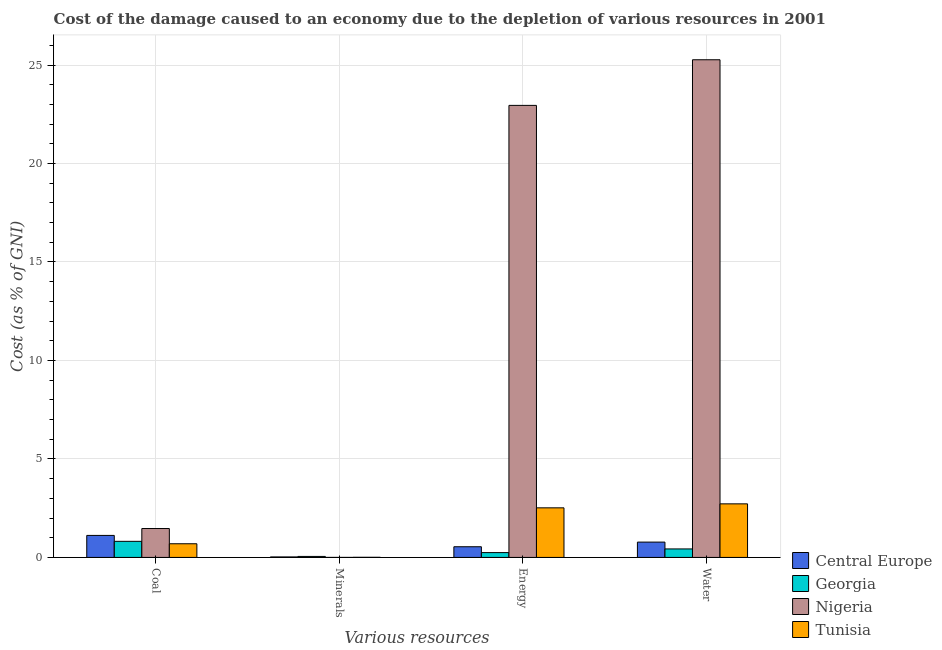How many groups of bars are there?
Offer a terse response. 4. Are the number of bars per tick equal to the number of legend labels?
Your answer should be very brief. Yes. Are the number of bars on each tick of the X-axis equal?
Give a very brief answer. Yes. How many bars are there on the 2nd tick from the left?
Provide a succinct answer. 4. How many bars are there on the 3rd tick from the right?
Your response must be concise. 4. What is the label of the 1st group of bars from the left?
Keep it short and to the point. Coal. What is the cost of damage due to depletion of minerals in Georgia?
Make the answer very short. 0.05. Across all countries, what is the maximum cost of damage due to depletion of coal?
Offer a terse response. 1.47. Across all countries, what is the minimum cost of damage due to depletion of water?
Ensure brevity in your answer.  0.43. In which country was the cost of damage due to depletion of energy maximum?
Ensure brevity in your answer.  Nigeria. In which country was the cost of damage due to depletion of minerals minimum?
Give a very brief answer. Nigeria. What is the total cost of damage due to depletion of coal in the graph?
Offer a terse response. 4.1. What is the difference between the cost of damage due to depletion of energy in Georgia and that in Tunisia?
Your response must be concise. -2.27. What is the difference between the cost of damage due to depletion of energy in Georgia and the cost of damage due to depletion of water in Tunisia?
Provide a short and direct response. -2.48. What is the average cost of damage due to depletion of coal per country?
Give a very brief answer. 1.02. What is the difference between the cost of damage due to depletion of minerals and cost of damage due to depletion of energy in Tunisia?
Your answer should be very brief. -2.51. What is the ratio of the cost of damage due to depletion of minerals in Tunisia to that in Central Europe?
Ensure brevity in your answer.  0.24. Is the cost of damage due to depletion of water in Central Europe less than that in Nigeria?
Your answer should be very brief. Yes. Is the difference between the cost of damage due to depletion of water in Tunisia and Central Europe greater than the difference between the cost of damage due to depletion of minerals in Tunisia and Central Europe?
Your answer should be very brief. Yes. What is the difference between the highest and the second highest cost of damage due to depletion of minerals?
Your response must be concise. 0.02. What is the difference between the highest and the lowest cost of damage due to depletion of water?
Ensure brevity in your answer.  24.84. In how many countries, is the cost of damage due to depletion of coal greater than the average cost of damage due to depletion of coal taken over all countries?
Ensure brevity in your answer.  2. Is the sum of the cost of damage due to depletion of energy in Tunisia and Georgia greater than the maximum cost of damage due to depletion of water across all countries?
Ensure brevity in your answer.  No. What does the 4th bar from the left in Energy represents?
Give a very brief answer. Tunisia. What does the 1st bar from the right in Energy represents?
Keep it short and to the point. Tunisia. Are the values on the major ticks of Y-axis written in scientific E-notation?
Your response must be concise. No. Does the graph contain any zero values?
Your answer should be compact. No. How are the legend labels stacked?
Provide a short and direct response. Vertical. What is the title of the graph?
Give a very brief answer. Cost of the damage caused to an economy due to the depletion of various resources in 2001 . Does "Central Europe" appear as one of the legend labels in the graph?
Ensure brevity in your answer.  Yes. What is the label or title of the X-axis?
Ensure brevity in your answer.  Various resources. What is the label or title of the Y-axis?
Give a very brief answer. Cost (as % of GNI). What is the Cost (as % of GNI) in Central Europe in Coal?
Ensure brevity in your answer.  1.12. What is the Cost (as % of GNI) of Georgia in Coal?
Your answer should be very brief. 0.82. What is the Cost (as % of GNI) of Nigeria in Coal?
Your answer should be very brief. 1.47. What is the Cost (as % of GNI) of Tunisia in Coal?
Your response must be concise. 0.69. What is the Cost (as % of GNI) in Central Europe in Minerals?
Ensure brevity in your answer.  0.03. What is the Cost (as % of GNI) of Georgia in Minerals?
Offer a terse response. 0.05. What is the Cost (as % of GNI) in Nigeria in Minerals?
Provide a succinct answer. 0. What is the Cost (as % of GNI) of Tunisia in Minerals?
Ensure brevity in your answer.  0.01. What is the Cost (as % of GNI) of Central Europe in Energy?
Keep it short and to the point. 0.54. What is the Cost (as % of GNI) in Georgia in Energy?
Your answer should be very brief. 0.24. What is the Cost (as % of GNI) of Nigeria in Energy?
Your response must be concise. 22.95. What is the Cost (as % of GNI) of Tunisia in Energy?
Your response must be concise. 2.52. What is the Cost (as % of GNI) of Central Europe in Water?
Your response must be concise. 0.78. What is the Cost (as % of GNI) of Georgia in Water?
Keep it short and to the point. 0.43. What is the Cost (as % of GNI) of Nigeria in Water?
Ensure brevity in your answer.  25.27. What is the Cost (as % of GNI) in Tunisia in Water?
Offer a terse response. 2.72. Across all Various resources, what is the maximum Cost (as % of GNI) of Central Europe?
Keep it short and to the point. 1.12. Across all Various resources, what is the maximum Cost (as % of GNI) of Georgia?
Ensure brevity in your answer.  0.82. Across all Various resources, what is the maximum Cost (as % of GNI) in Nigeria?
Provide a succinct answer. 25.27. Across all Various resources, what is the maximum Cost (as % of GNI) of Tunisia?
Your answer should be compact. 2.72. Across all Various resources, what is the minimum Cost (as % of GNI) in Central Europe?
Offer a terse response. 0.03. Across all Various resources, what is the minimum Cost (as % of GNI) of Georgia?
Your answer should be very brief. 0.05. Across all Various resources, what is the minimum Cost (as % of GNI) in Nigeria?
Give a very brief answer. 0. Across all Various resources, what is the minimum Cost (as % of GNI) of Tunisia?
Keep it short and to the point. 0.01. What is the total Cost (as % of GNI) in Central Europe in the graph?
Give a very brief answer. 2.46. What is the total Cost (as % of GNI) of Georgia in the graph?
Your response must be concise. 1.54. What is the total Cost (as % of GNI) of Nigeria in the graph?
Ensure brevity in your answer.  49.68. What is the total Cost (as % of GNI) in Tunisia in the graph?
Provide a succinct answer. 5.94. What is the difference between the Cost (as % of GNI) of Central Europe in Coal and that in Minerals?
Provide a succinct answer. 1.09. What is the difference between the Cost (as % of GNI) of Georgia in Coal and that in Minerals?
Make the answer very short. 0.77. What is the difference between the Cost (as % of GNI) in Nigeria in Coal and that in Minerals?
Your answer should be compact. 1.47. What is the difference between the Cost (as % of GNI) of Tunisia in Coal and that in Minerals?
Give a very brief answer. 0.69. What is the difference between the Cost (as % of GNI) in Central Europe in Coal and that in Energy?
Offer a terse response. 0.58. What is the difference between the Cost (as % of GNI) of Georgia in Coal and that in Energy?
Provide a short and direct response. 0.57. What is the difference between the Cost (as % of GNI) in Nigeria in Coal and that in Energy?
Your answer should be compact. -21.48. What is the difference between the Cost (as % of GNI) in Tunisia in Coal and that in Energy?
Offer a very short reply. -1.82. What is the difference between the Cost (as % of GNI) of Central Europe in Coal and that in Water?
Offer a very short reply. 0.34. What is the difference between the Cost (as % of GNI) of Georgia in Coal and that in Water?
Provide a short and direct response. 0.39. What is the difference between the Cost (as % of GNI) of Nigeria in Coal and that in Water?
Provide a short and direct response. -23.8. What is the difference between the Cost (as % of GNI) of Tunisia in Coal and that in Water?
Your response must be concise. -2.03. What is the difference between the Cost (as % of GNI) of Central Europe in Minerals and that in Energy?
Your answer should be very brief. -0.52. What is the difference between the Cost (as % of GNI) of Georgia in Minerals and that in Energy?
Offer a terse response. -0.19. What is the difference between the Cost (as % of GNI) of Nigeria in Minerals and that in Energy?
Provide a short and direct response. -22.95. What is the difference between the Cost (as % of GNI) of Tunisia in Minerals and that in Energy?
Give a very brief answer. -2.51. What is the difference between the Cost (as % of GNI) in Central Europe in Minerals and that in Water?
Offer a very short reply. -0.75. What is the difference between the Cost (as % of GNI) of Georgia in Minerals and that in Water?
Your answer should be compact. -0.38. What is the difference between the Cost (as % of GNI) in Nigeria in Minerals and that in Water?
Give a very brief answer. -25.27. What is the difference between the Cost (as % of GNI) in Tunisia in Minerals and that in Water?
Your response must be concise. -2.71. What is the difference between the Cost (as % of GNI) in Central Europe in Energy and that in Water?
Your response must be concise. -0.24. What is the difference between the Cost (as % of GNI) of Georgia in Energy and that in Water?
Ensure brevity in your answer.  -0.19. What is the difference between the Cost (as % of GNI) of Nigeria in Energy and that in Water?
Ensure brevity in your answer.  -2.32. What is the difference between the Cost (as % of GNI) of Tunisia in Energy and that in Water?
Keep it short and to the point. -0.2. What is the difference between the Cost (as % of GNI) of Central Europe in Coal and the Cost (as % of GNI) of Georgia in Minerals?
Provide a succinct answer. 1.07. What is the difference between the Cost (as % of GNI) in Central Europe in Coal and the Cost (as % of GNI) in Nigeria in Minerals?
Keep it short and to the point. 1.12. What is the difference between the Cost (as % of GNI) of Central Europe in Coal and the Cost (as % of GNI) of Tunisia in Minerals?
Your answer should be very brief. 1.11. What is the difference between the Cost (as % of GNI) of Georgia in Coal and the Cost (as % of GNI) of Nigeria in Minerals?
Keep it short and to the point. 0.82. What is the difference between the Cost (as % of GNI) of Georgia in Coal and the Cost (as % of GNI) of Tunisia in Minerals?
Your response must be concise. 0.81. What is the difference between the Cost (as % of GNI) in Nigeria in Coal and the Cost (as % of GNI) in Tunisia in Minerals?
Your answer should be very brief. 1.46. What is the difference between the Cost (as % of GNI) in Central Europe in Coal and the Cost (as % of GNI) in Georgia in Energy?
Give a very brief answer. 0.87. What is the difference between the Cost (as % of GNI) of Central Europe in Coal and the Cost (as % of GNI) of Nigeria in Energy?
Make the answer very short. -21.83. What is the difference between the Cost (as % of GNI) of Central Europe in Coal and the Cost (as % of GNI) of Tunisia in Energy?
Offer a terse response. -1.4. What is the difference between the Cost (as % of GNI) in Georgia in Coal and the Cost (as % of GNI) in Nigeria in Energy?
Your response must be concise. -22.13. What is the difference between the Cost (as % of GNI) in Georgia in Coal and the Cost (as % of GNI) in Tunisia in Energy?
Make the answer very short. -1.7. What is the difference between the Cost (as % of GNI) in Nigeria in Coal and the Cost (as % of GNI) in Tunisia in Energy?
Provide a short and direct response. -1.05. What is the difference between the Cost (as % of GNI) in Central Europe in Coal and the Cost (as % of GNI) in Georgia in Water?
Give a very brief answer. 0.69. What is the difference between the Cost (as % of GNI) of Central Europe in Coal and the Cost (as % of GNI) of Nigeria in Water?
Provide a succinct answer. -24.15. What is the difference between the Cost (as % of GNI) of Central Europe in Coal and the Cost (as % of GNI) of Tunisia in Water?
Provide a short and direct response. -1.6. What is the difference between the Cost (as % of GNI) in Georgia in Coal and the Cost (as % of GNI) in Nigeria in Water?
Keep it short and to the point. -24.45. What is the difference between the Cost (as % of GNI) of Georgia in Coal and the Cost (as % of GNI) of Tunisia in Water?
Keep it short and to the point. -1.9. What is the difference between the Cost (as % of GNI) in Nigeria in Coal and the Cost (as % of GNI) in Tunisia in Water?
Provide a short and direct response. -1.25. What is the difference between the Cost (as % of GNI) of Central Europe in Minerals and the Cost (as % of GNI) of Georgia in Energy?
Offer a very short reply. -0.22. What is the difference between the Cost (as % of GNI) of Central Europe in Minerals and the Cost (as % of GNI) of Nigeria in Energy?
Your answer should be very brief. -22.92. What is the difference between the Cost (as % of GNI) of Central Europe in Minerals and the Cost (as % of GNI) of Tunisia in Energy?
Offer a terse response. -2.49. What is the difference between the Cost (as % of GNI) in Georgia in Minerals and the Cost (as % of GNI) in Nigeria in Energy?
Keep it short and to the point. -22.9. What is the difference between the Cost (as % of GNI) of Georgia in Minerals and the Cost (as % of GNI) of Tunisia in Energy?
Provide a succinct answer. -2.47. What is the difference between the Cost (as % of GNI) in Nigeria in Minerals and the Cost (as % of GNI) in Tunisia in Energy?
Provide a succinct answer. -2.52. What is the difference between the Cost (as % of GNI) in Central Europe in Minerals and the Cost (as % of GNI) in Georgia in Water?
Your response must be concise. -0.41. What is the difference between the Cost (as % of GNI) in Central Europe in Minerals and the Cost (as % of GNI) in Nigeria in Water?
Provide a short and direct response. -25.24. What is the difference between the Cost (as % of GNI) of Central Europe in Minerals and the Cost (as % of GNI) of Tunisia in Water?
Ensure brevity in your answer.  -2.69. What is the difference between the Cost (as % of GNI) in Georgia in Minerals and the Cost (as % of GNI) in Nigeria in Water?
Provide a short and direct response. -25.22. What is the difference between the Cost (as % of GNI) in Georgia in Minerals and the Cost (as % of GNI) in Tunisia in Water?
Make the answer very short. -2.67. What is the difference between the Cost (as % of GNI) in Nigeria in Minerals and the Cost (as % of GNI) in Tunisia in Water?
Provide a succinct answer. -2.72. What is the difference between the Cost (as % of GNI) in Central Europe in Energy and the Cost (as % of GNI) in Nigeria in Water?
Provide a short and direct response. -24.72. What is the difference between the Cost (as % of GNI) of Central Europe in Energy and the Cost (as % of GNI) of Tunisia in Water?
Make the answer very short. -2.18. What is the difference between the Cost (as % of GNI) of Georgia in Energy and the Cost (as % of GNI) of Nigeria in Water?
Offer a terse response. -25.02. What is the difference between the Cost (as % of GNI) in Georgia in Energy and the Cost (as % of GNI) in Tunisia in Water?
Give a very brief answer. -2.48. What is the difference between the Cost (as % of GNI) of Nigeria in Energy and the Cost (as % of GNI) of Tunisia in Water?
Your response must be concise. 20.23. What is the average Cost (as % of GNI) of Central Europe per Various resources?
Provide a succinct answer. 0.62. What is the average Cost (as % of GNI) of Georgia per Various resources?
Ensure brevity in your answer.  0.39. What is the average Cost (as % of GNI) in Nigeria per Various resources?
Offer a very short reply. 12.42. What is the average Cost (as % of GNI) of Tunisia per Various resources?
Make the answer very short. 1.48. What is the difference between the Cost (as % of GNI) of Central Europe and Cost (as % of GNI) of Georgia in Coal?
Your response must be concise. 0.3. What is the difference between the Cost (as % of GNI) in Central Europe and Cost (as % of GNI) in Nigeria in Coal?
Your answer should be very brief. -0.35. What is the difference between the Cost (as % of GNI) of Central Europe and Cost (as % of GNI) of Tunisia in Coal?
Keep it short and to the point. 0.42. What is the difference between the Cost (as % of GNI) in Georgia and Cost (as % of GNI) in Nigeria in Coal?
Keep it short and to the point. -0.65. What is the difference between the Cost (as % of GNI) in Georgia and Cost (as % of GNI) in Tunisia in Coal?
Keep it short and to the point. 0.12. What is the difference between the Cost (as % of GNI) in Nigeria and Cost (as % of GNI) in Tunisia in Coal?
Your answer should be compact. 0.77. What is the difference between the Cost (as % of GNI) of Central Europe and Cost (as % of GNI) of Georgia in Minerals?
Keep it short and to the point. -0.02. What is the difference between the Cost (as % of GNI) of Central Europe and Cost (as % of GNI) of Nigeria in Minerals?
Your answer should be compact. 0.03. What is the difference between the Cost (as % of GNI) in Central Europe and Cost (as % of GNI) in Tunisia in Minerals?
Your answer should be very brief. 0.02. What is the difference between the Cost (as % of GNI) in Georgia and Cost (as % of GNI) in Nigeria in Minerals?
Your response must be concise. 0.05. What is the difference between the Cost (as % of GNI) of Georgia and Cost (as % of GNI) of Tunisia in Minerals?
Offer a very short reply. 0.04. What is the difference between the Cost (as % of GNI) of Nigeria and Cost (as % of GNI) of Tunisia in Minerals?
Keep it short and to the point. -0.01. What is the difference between the Cost (as % of GNI) of Central Europe and Cost (as % of GNI) of Georgia in Energy?
Your answer should be compact. 0.3. What is the difference between the Cost (as % of GNI) in Central Europe and Cost (as % of GNI) in Nigeria in Energy?
Offer a very short reply. -22.41. What is the difference between the Cost (as % of GNI) of Central Europe and Cost (as % of GNI) of Tunisia in Energy?
Offer a terse response. -1.98. What is the difference between the Cost (as % of GNI) of Georgia and Cost (as % of GNI) of Nigeria in Energy?
Offer a very short reply. -22.71. What is the difference between the Cost (as % of GNI) of Georgia and Cost (as % of GNI) of Tunisia in Energy?
Offer a terse response. -2.27. What is the difference between the Cost (as % of GNI) of Nigeria and Cost (as % of GNI) of Tunisia in Energy?
Offer a terse response. 20.43. What is the difference between the Cost (as % of GNI) in Central Europe and Cost (as % of GNI) in Georgia in Water?
Provide a succinct answer. 0.35. What is the difference between the Cost (as % of GNI) of Central Europe and Cost (as % of GNI) of Nigeria in Water?
Keep it short and to the point. -24.49. What is the difference between the Cost (as % of GNI) in Central Europe and Cost (as % of GNI) in Tunisia in Water?
Your response must be concise. -1.94. What is the difference between the Cost (as % of GNI) of Georgia and Cost (as % of GNI) of Nigeria in Water?
Your answer should be compact. -24.84. What is the difference between the Cost (as % of GNI) of Georgia and Cost (as % of GNI) of Tunisia in Water?
Keep it short and to the point. -2.29. What is the difference between the Cost (as % of GNI) of Nigeria and Cost (as % of GNI) of Tunisia in Water?
Your response must be concise. 22.55. What is the ratio of the Cost (as % of GNI) in Central Europe in Coal to that in Minerals?
Keep it short and to the point. 43.96. What is the ratio of the Cost (as % of GNI) of Georgia in Coal to that in Minerals?
Keep it short and to the point. 16.23. What is the ratio of the Cost (as % of GNI) in Nigeria in Coal to that in Minerals?
Keep it short and to the point. 3718.58. What is the ratio of the Cost (as % of GNI) of Tunisia in Coal to that in Minerals?
Make the answer very short. 113.82. What is the ratio of the Cost (as % of GNI) in Central Europe in Coal to that in Energy?
Offer a terse response. 2.06. What is the ratio of the Cost (as % of GNI) in Georgia in Coal to that in Energy?
Give a very brief answer. 3.34. What is the ratio of the Cost (as % of GNI) of Nigeria in Coal to that in Energy?
Ensure brevity in your answer.  0.06. What is the ratio of the Cost (as % of GNI) in Tunisia in Coal to that in Energy?
Ensure brevity in your answer.  0.28. What is the ratio of the Cost (as % of GNI) of Central Europe in Coal to that in Water?
Your answer should be compact. 1.44. What is the ratio of the Cost (as % of GNI) of Georgia in Coal to that in Water?
Provide a succinct answer. 1.89. What is the ratio of the Cost (as % of GNI) of Nigeria in Coal to that in Water?
Your answer should be compact. 0.06. What is the ratio of the Cost (as % of GNI) in Tunisia in Coal to that in Water?
Keep it short and to the point. 0.26. What is the ratio of the Cost (as % of GNI) in Central Europe in Minerals to that in Energy?
Your answer should be compact. 0.05. What is the ratio of the Cost (as % of GNI) of Georgia in Minerals to that in Energy?
Provide a succinct answer. 0.21. What is the ratio of the Cost (as % of GNI) in Nigeria in Minerals to that in Energy?
Keep it short and to the point. 0. What is the ratio of the Cost (as % of GNI) of Tunisia in Minerals to that in Energy?
Your answer should be compact. 0. What is the ratio of the Cost (as % of GNI) in Central Europe in Minerals to that in Water?
Offer a very short reply. 0.03. What is the ratio of the Cost (as % of GNI) of Georgia in Minerals to that in Water?
Offer a very short reply. 0.12. What is the ratio of the Cost (as % of GNI) of Tunisia in Minerals to that in Water?
Your answer should be compact. 0. What is the ratio of the Cost (as % of GNI) of Central Europe in Energy to that in Water?
Your answer should be very brief. 0.7. What is the ratio of the Cost (as % of GNI) in Georgia in Energy to that in Water?
Provide a short and direct response. 0.57. What is the ratio of the Cost (as % of GNI) of Nigeria in Energy to that in Water?
Keep it short and to the point. 0.91. What is the ratio of the Cost (as % of GNI) in Tunisia in Energy to that in Water?
Ensure brevity in your answer.  0.93. What is the difference between the highest and the second highest Cost (as % of GNI) of Central Europe?
Give a very brief answer. 0.34. What is the difference between the highest and the second highest Cost (as % of GNI) of Georgia?
Provide a short and direct response. 0.39. What is the difference between the highest and the second highest Cost (as % of GNI) of Nigeria?
Provide a short and direct response. 2.32. What is the difference between the highest and the second highest Cost (as % of GNI) of Tunisia?
Provide a succinct answer. 0.2. What is the difference between the highest and the lowest Cost (as % of GNI) of Central Europe?
Your response must be concise. 1.09. What is the difference between the highest and the lowest Cost (as % of GNI) of Georgia?
Your answer should be very brief. 0.77. What is the difference between the highest and the lowest Cost (as % of GNI) of Nigeria?
Your answer should be very brief. 25.27. What is the difference between the highest and the lowest Cost (as % of GNI) of Tunisia?
Offer a terse response. 2.71. 